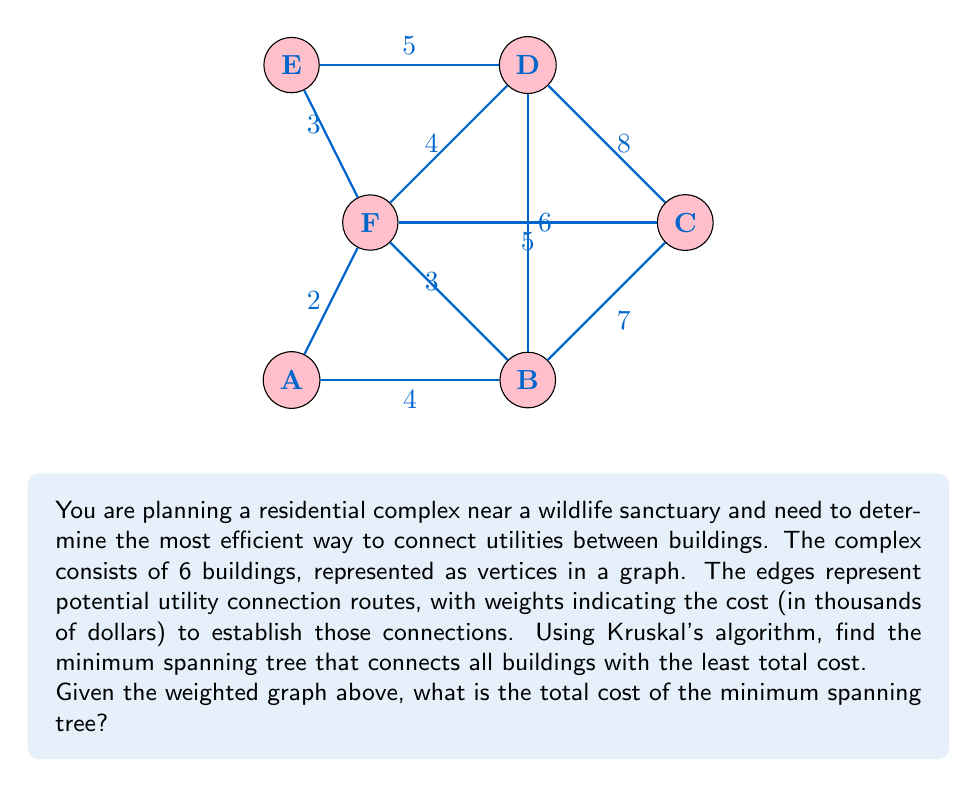Show me your answer to this math problem. To solve this problem, we'll use Kruskal's algorithm to find the minimum spanning tree (MST) of the given graph. Kruskal's algorithm works by sorting all edges by weight and then adding them to the MST if they don't create a cycle.

Step 1: Sort all edges by weight (cost) in ascending order:
1. A-F: 2
2. E-F: 3
3. B-F: 3
4. A-B: 4
5. D-F: 4
6. D-E: 5
7. C-F: 5
8. B-D: 6
9. B-C: 7
10. C-D: 8

Step 2: Apply Kruskal's algorithm:
1. Add A-F (2)
2. Add E-F (3)
3. Add B-F (3)
4. Add A-B (4) (skip, creates a cycle)
5. Add D-F (4)
6. Add D-E (5) (skip, creates a cycle)
7. Add C-F (5)

At this point, we have connected all 6 vertices without creating any cycles, so we stop.

Step 3: Calculate the total cost of the MST:
$$\text{Total Cost} = 2 + 3 + 3 + 4 + 5 = 17$$

Therefore, the minimum spanning tree has a total cost of 17 thousand dollars.
Answer: $17,000 